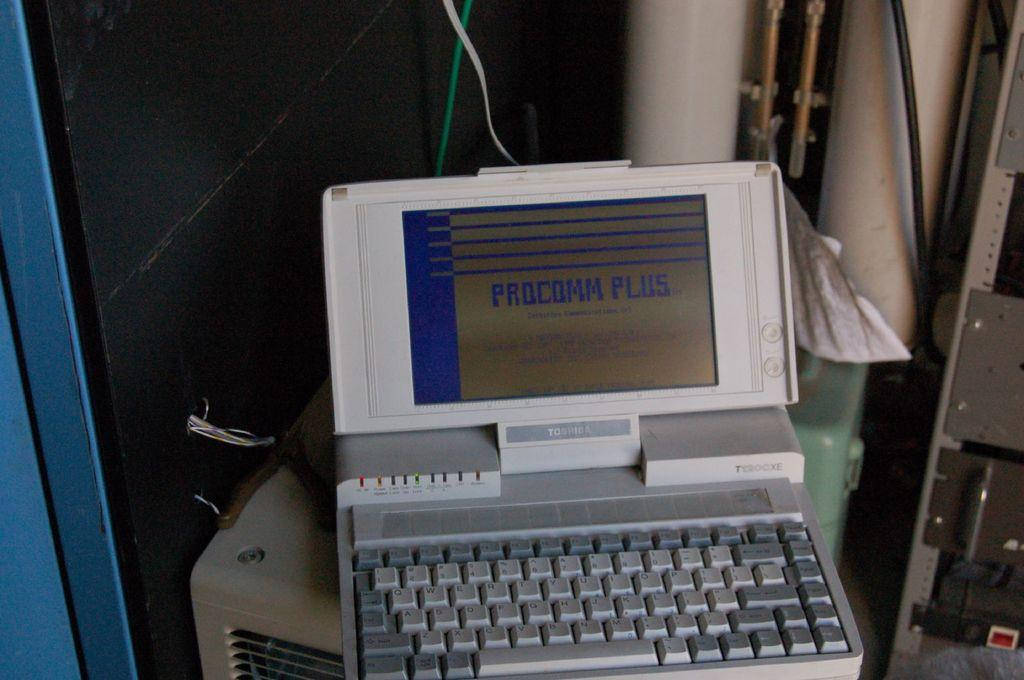Provide a one-sentence caption for the provided image. Picture of a laptop that includes information on procomm plus. 